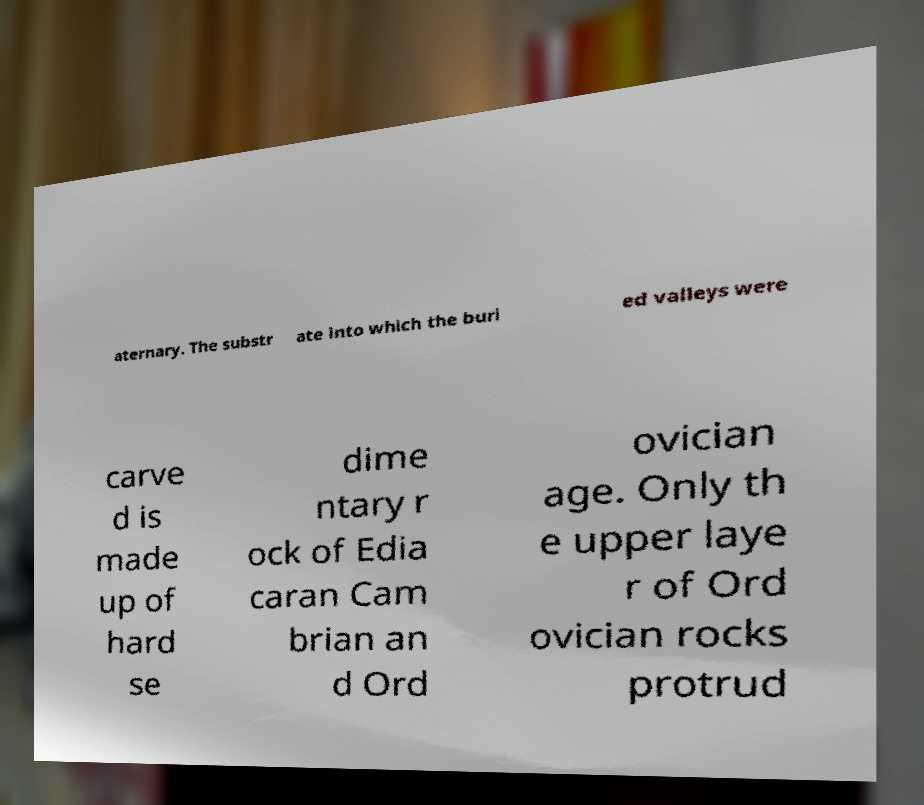Can you read and provide the text displayed in the image?This photo seems to have some interesting text. Can you extract and type it out for me? aternary. The substr ate into which the buri ed valleys were carve d is made up of hard se dime ntary r ock of Edia caran Cam brian an d Ord ovician age. Only th e upper laye r of Ord ovician rocks protrud 